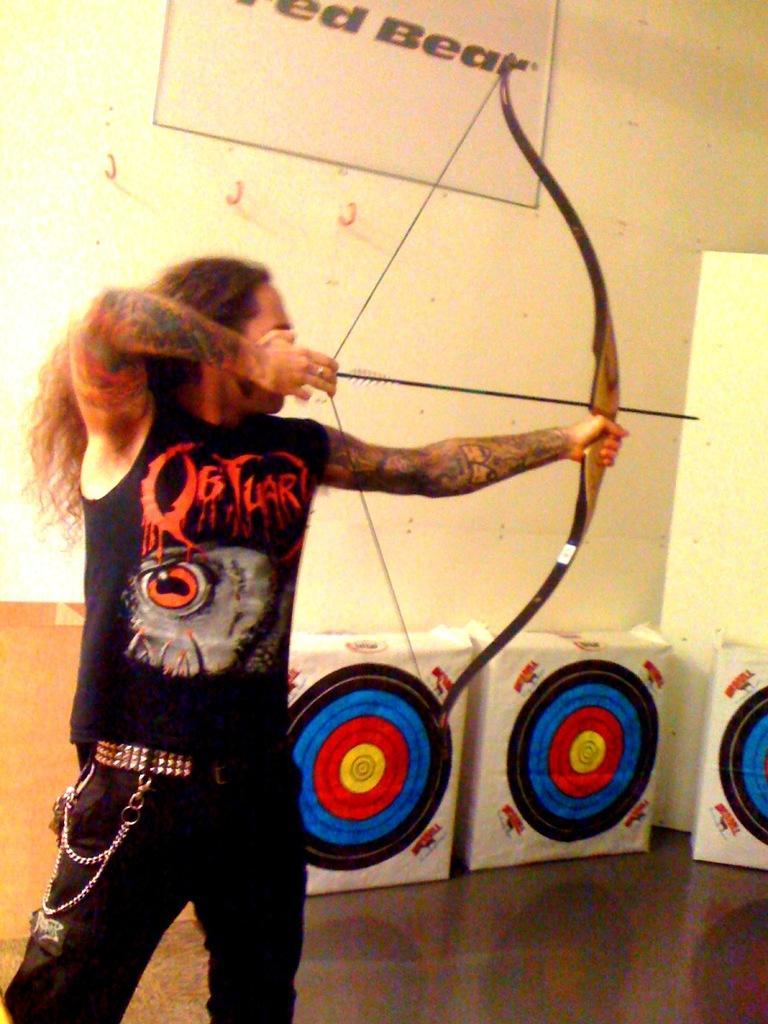Describe this image in one or two sentences. In this image, I can see a person standing and holding a bow and arrow. These look like the boards. I can see a poster, which is attached to the wall. I think these are the hangers hooks. 